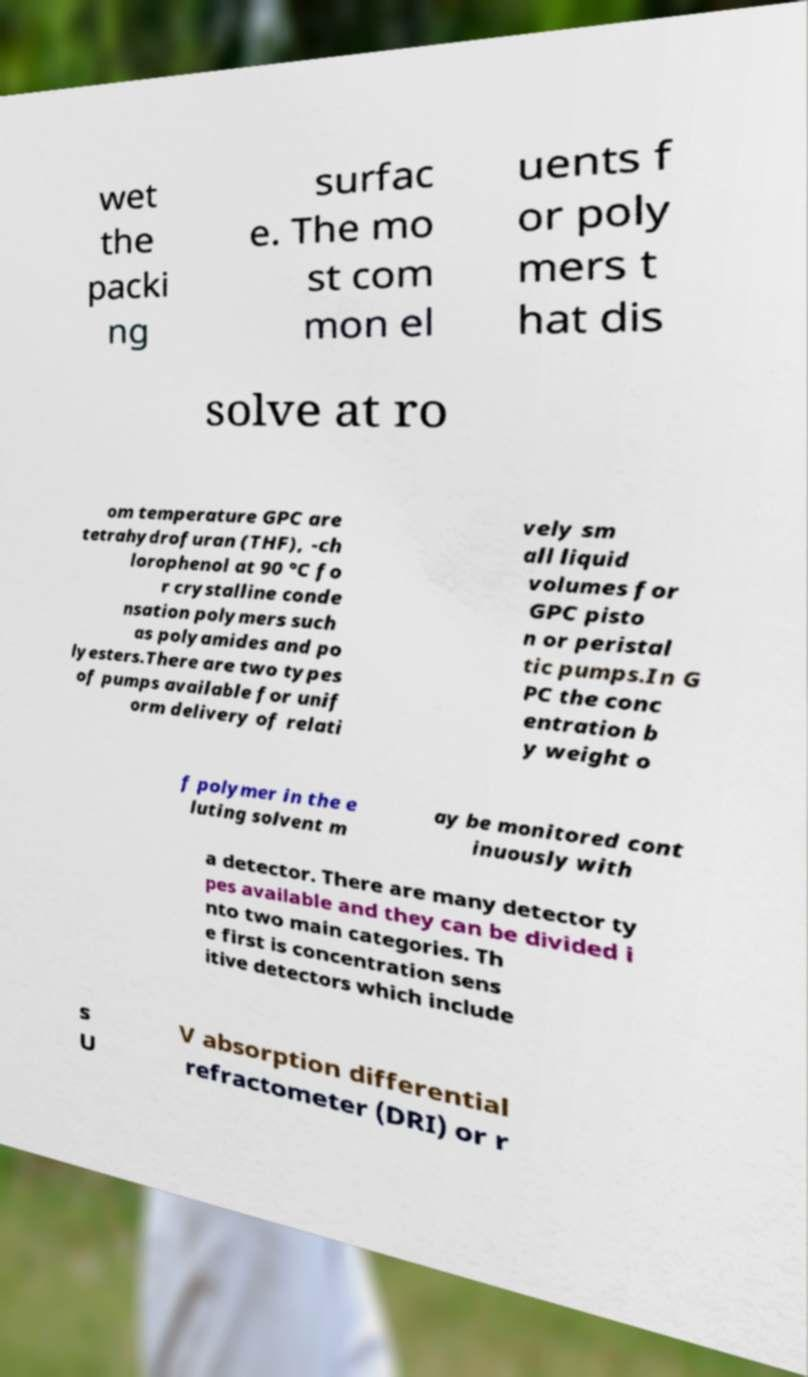Could you assist in decoding the text presented in this image and type it out clearly? wet the packi ng surfac e. The mo st com mon el uents f or poly mers t hat dis solve at ro om temperature GPC are tetrahydrofuran (THF), -ch lorophenol at 90 °C fo r crystalline conde nsation polymers such as polyamides and po lyesters.There are two types of pumps available for unif orm delivery of relati vely sm all liquid volumes for GPC pisto n or peristal tic pumps.In G PC the conc entration b y weight o f polymer in the e luting solvent m ay be monitored cont inuously with a detector. There are many detector ty pes available and they can be divided i nto two main categories. Th e first is concentration sens itive detectors which include s U V absorption differential refractometer (DRI) or r 